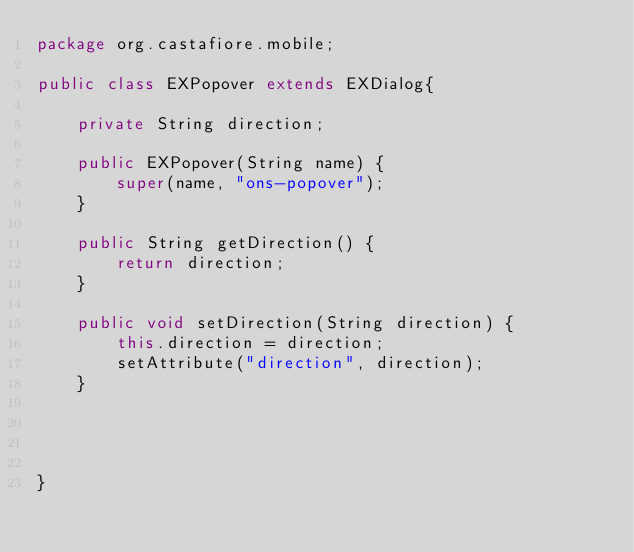<code> <loc_0><loc_0><loc_500><loc_500><_Java_>package org.castafiore.mobile;

public class EXPopover extends EXDialog{
	
	private String direction;

	public EXPopover(String name) {
		super(name, "ons-popover");
	}

	public String getDirection() {
		return direction;
	}

	public void setDirection(String direction) {
		this.direction = direction;
		setAttribute("direction", direction);
	}

	
	
	
}
</code> 